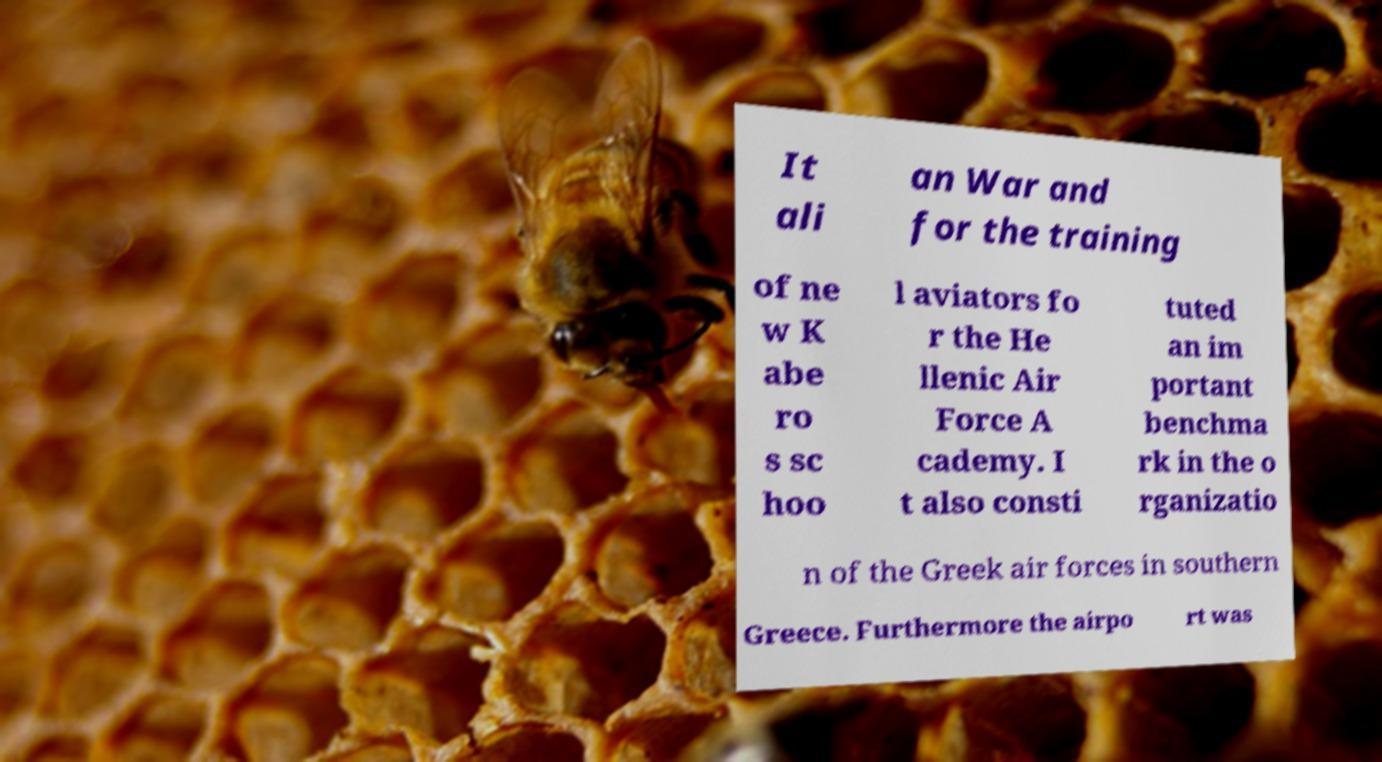I need the written content from this picture converted into text. Can you do that? It ali an War and for the training of ne w K abe ro s sc hoo l aviators fo r the He llenic Air Force A cademy. I t also consti tuted an im portant benchma rk in the o rganizatio n of the Greek air forces in southern Greece. Furthermore the airpo rt was 